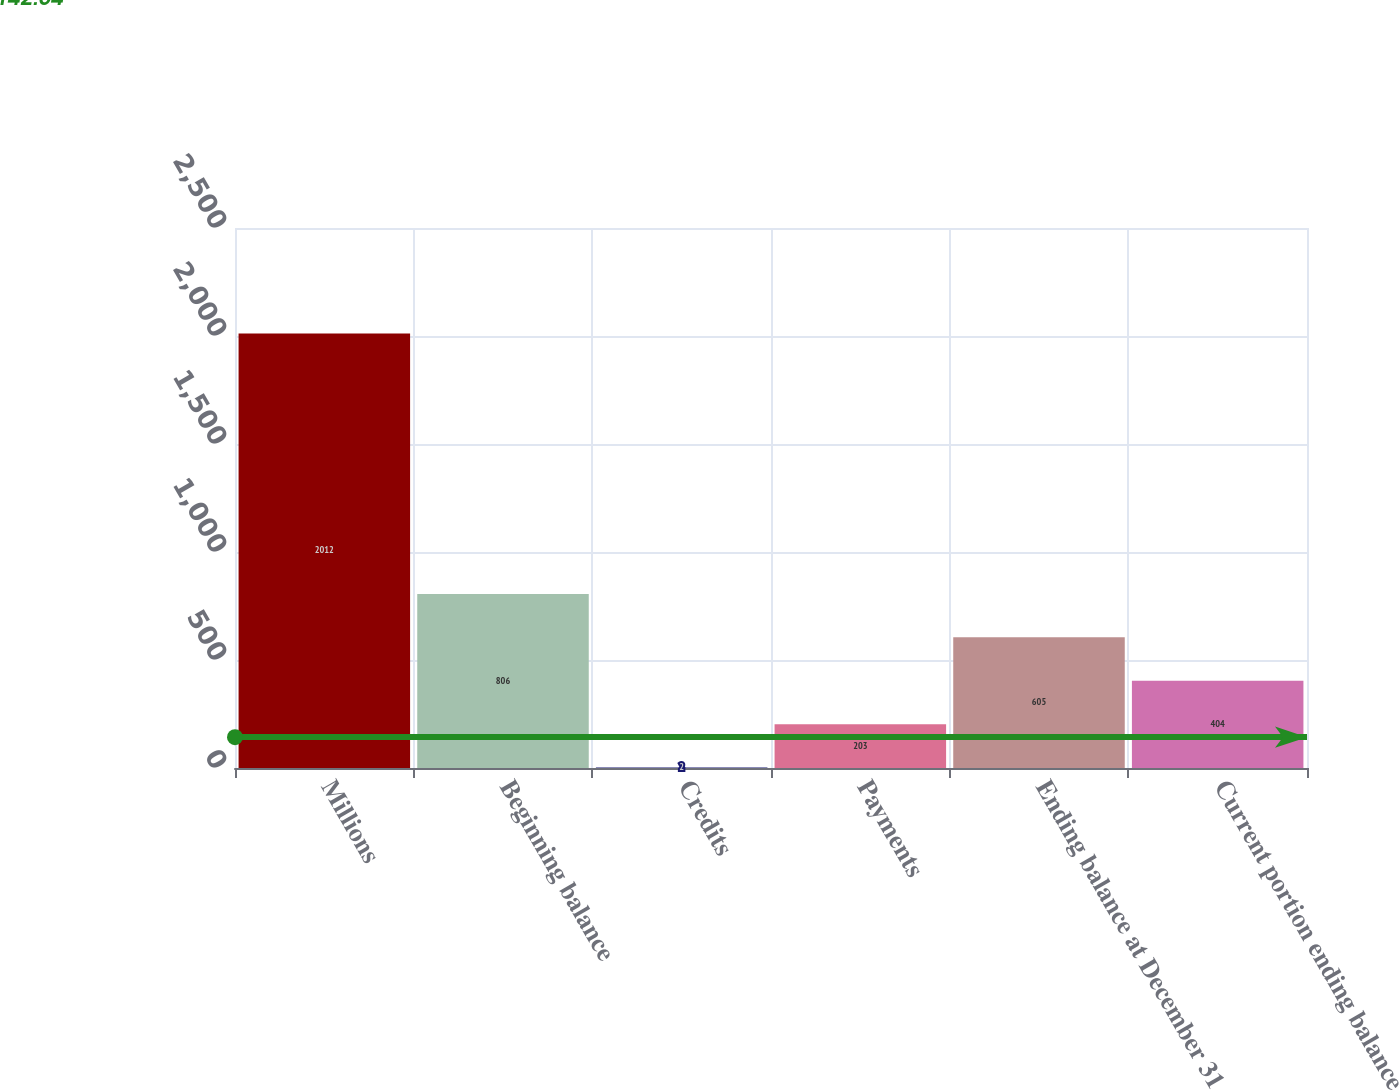Convert chart. <chart><loc_0><loc_0><loc_500><loc_500><bar_chart><fcel>Millions<fcel>Beginning balance<fcel>Credits<fcel>Payments<fcel>Ending balance at December 31<fcel>Current portion ending balance<nl><fcel>2012<fcel>806<fcel>2<fcel>203<fcel>605<fcel>404<nl></chart> 